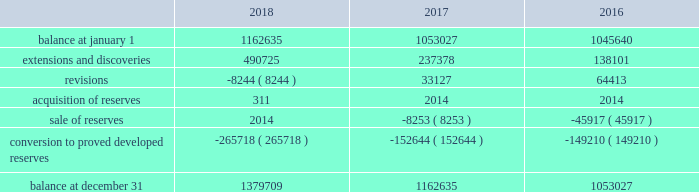Eog resources , inc .
Supplemental information to consolidated financial statements ( continued ) net proved undeveloped reserves .
The table presents the changes in eog's total proved undeveloped reserves during 2018 , 2017 and 2016 ( in mboe ) : .
For the twelve-month period ended december 31 , 2018 , total puds increased by 217 mmboe to 1380 mmboe .
Eog added approximately 31 mmboe of puds through drilling activities where the wells were drilled but significant expenditures remained for completion .
Based on the technology employed by eog to identify and record puds ( see discussion of technology employed on pages f-36 and f-37 of this annual report on form 10-k ) , eog added 460 mmboe .
The pud additions were primarily in the permian basin , anadarko basin , the eagle ford and , to a lesser extent , the rocky mountain area , and 80% ( 80 % ) of the additions were crude oil and condensate and ngls .
During 2018 , eog drilled and transferred 266 mmboe of puds to proved developed reserves at a total capital cost of $ 2745 million .
All puds , including drilled but uncompleted wells ( ducs ) , are scheduled for completion within five years of the original reserve booking .
For the twelve-month period ended december 31 , 2017 , total puds increased by 110 mmboe to 1163 mmboe .
Eog added approximately 38 mmboe of puds through drilling activities where the wells were drilled but significant expenditures remained for completion .
Based on the technology employed by eog to identify and record puds , eog added 199 mmboe .
The pud additions were primarily in the permian basin and , to a lesser extent , the eagle ford and the rocky mountain area , and 74% ( 74 % ) of the additions were crude oil and condensate and ngls .
During 2017 , eog drilled and transferred 153 mmboe of puds to proved developed reserves at a total capital cost of $ 1440 million .
Revisions of puds totaled positive 33 mmboe , primarily due to updated type curves resulting from improved performance of offsetting wells in the permian basin , the impact of increases in the average crude oil and natural gas prices used in the december 31 , 2017 , reserves estimation as compared to the prices used in the prior year estimate , and lower costs .
During 2017 , eog sold or exchanged 8 mmboe of puds primarily in the permian basin .
For the twelve-month period ended december 31 , 2016 , total puds increased by 7 mmboe to 1053 mmboe .
Eog added approximately 21 mmboe of puds through drilling activities where the wells were drilled but significant expenditures remained for completion .
Based on the technology employed by eog to identify and record puds , eog added 117 mmboe .
The pud additions were primarily in the permian basin and , to a lesser extent , the rocky mountain area , and 82% ( 82 % ) of the additions were crude oil and condensate and ngls .
During 2016 , eog drilled and transferred 149 mmboe of puds to proved developed reserves at a total capital cost of $ 1230 million .
Revisions of puds totaled positive 64 mmboe , primarily due to improved well performance , primarily in the delaware basin , and lower production costs , partially offset by the impact of decreases in the average crude oil and natural gas prices used in the december 31 , 2016 , reserves estimation as compared to the prices used in the prior year estimate .
During 2016 , eog sold 46 mmboe of puds primarily in the haynesville play. .
What was the increase observed in the initial balance between 2017 and 2018? 
Rationale: it is the value of the initial balance of 2018 divided by the 2017's , then subtracted 1 and turned into a percentage .
Computations: ((1162635 / 1053027) - 1)
Answer: 0.10409. 